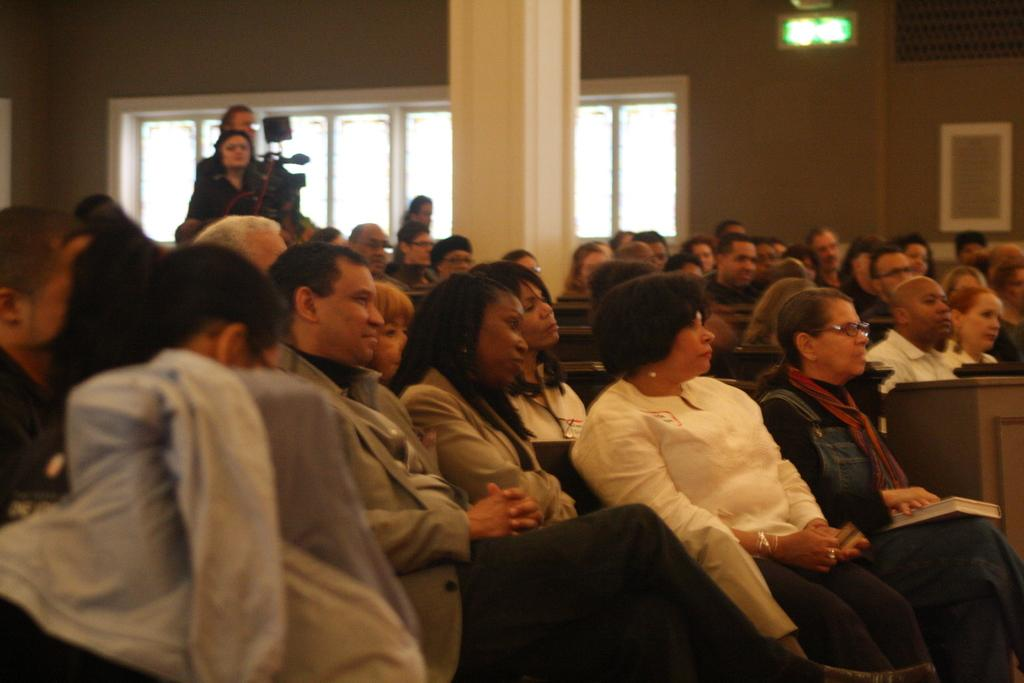How many individuals are present in the image? There are many people in the image. What are the people doing in the image? The people are sitting on chairs. What thrill can be experienced by the people in the image? There is no indication of a thrill or any specific activity in the image; the people are simply sitting on chairs. 